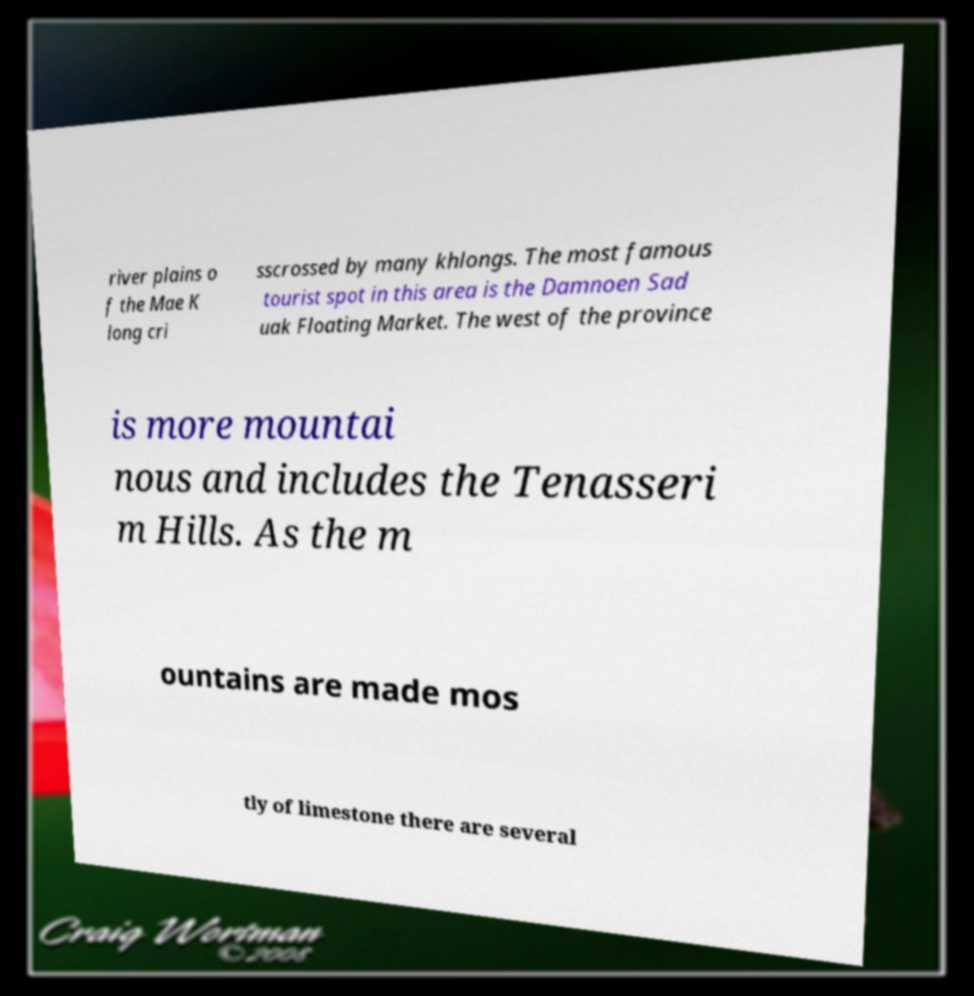What messages or text are displayed in this image? I need them in a readable, typed format. river plains o f the Mae K long cri sscrossed by many khlongs. The most famous tourist spot in this area is the Damnoen Sad uak Floating Market. The west of the province is more mountai nous and includes the Tenasseri m Hills. As the m ountains are made mos tly of limestone there are several 